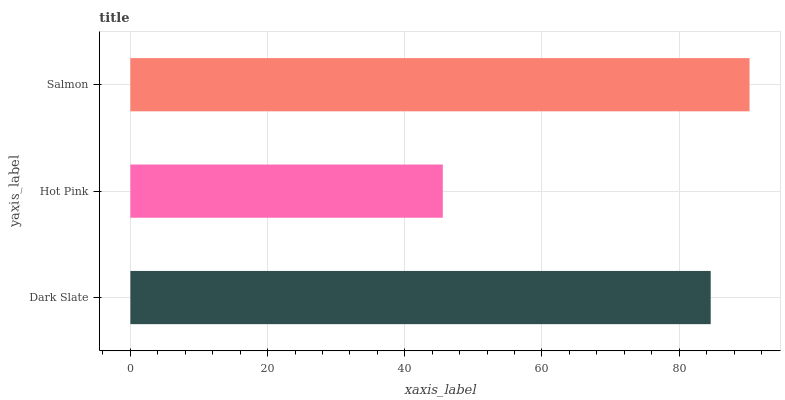Is Hot Pink the minimum?
Answer yes or no. Yes. Is Salmon the maximum?
Answer yes or no. Yes. Is Salmon the minimum?
Answer yes or no. No. Is Hot Pink the maximum?
Answer yes or no. No. Is Salmon greater than Hot Pink?
Answer yes or no. Yes. Is Hot Pink less than Salmon?
Answer yes or no. Yes. Is Hot Pink greater than Salmon?
Answer yes or no. No. Is Salmon less than Hot Pink?
Answer yes or no. No. Is Dark Slate the high median?
Answer yes or no. Yes. Is Dark Slate the low median?
Answer yes or no. Yes. Is Salmon the high median?
Answer yes or no. No. Is Hot Pink the low median?
Answer yes or no. No. 